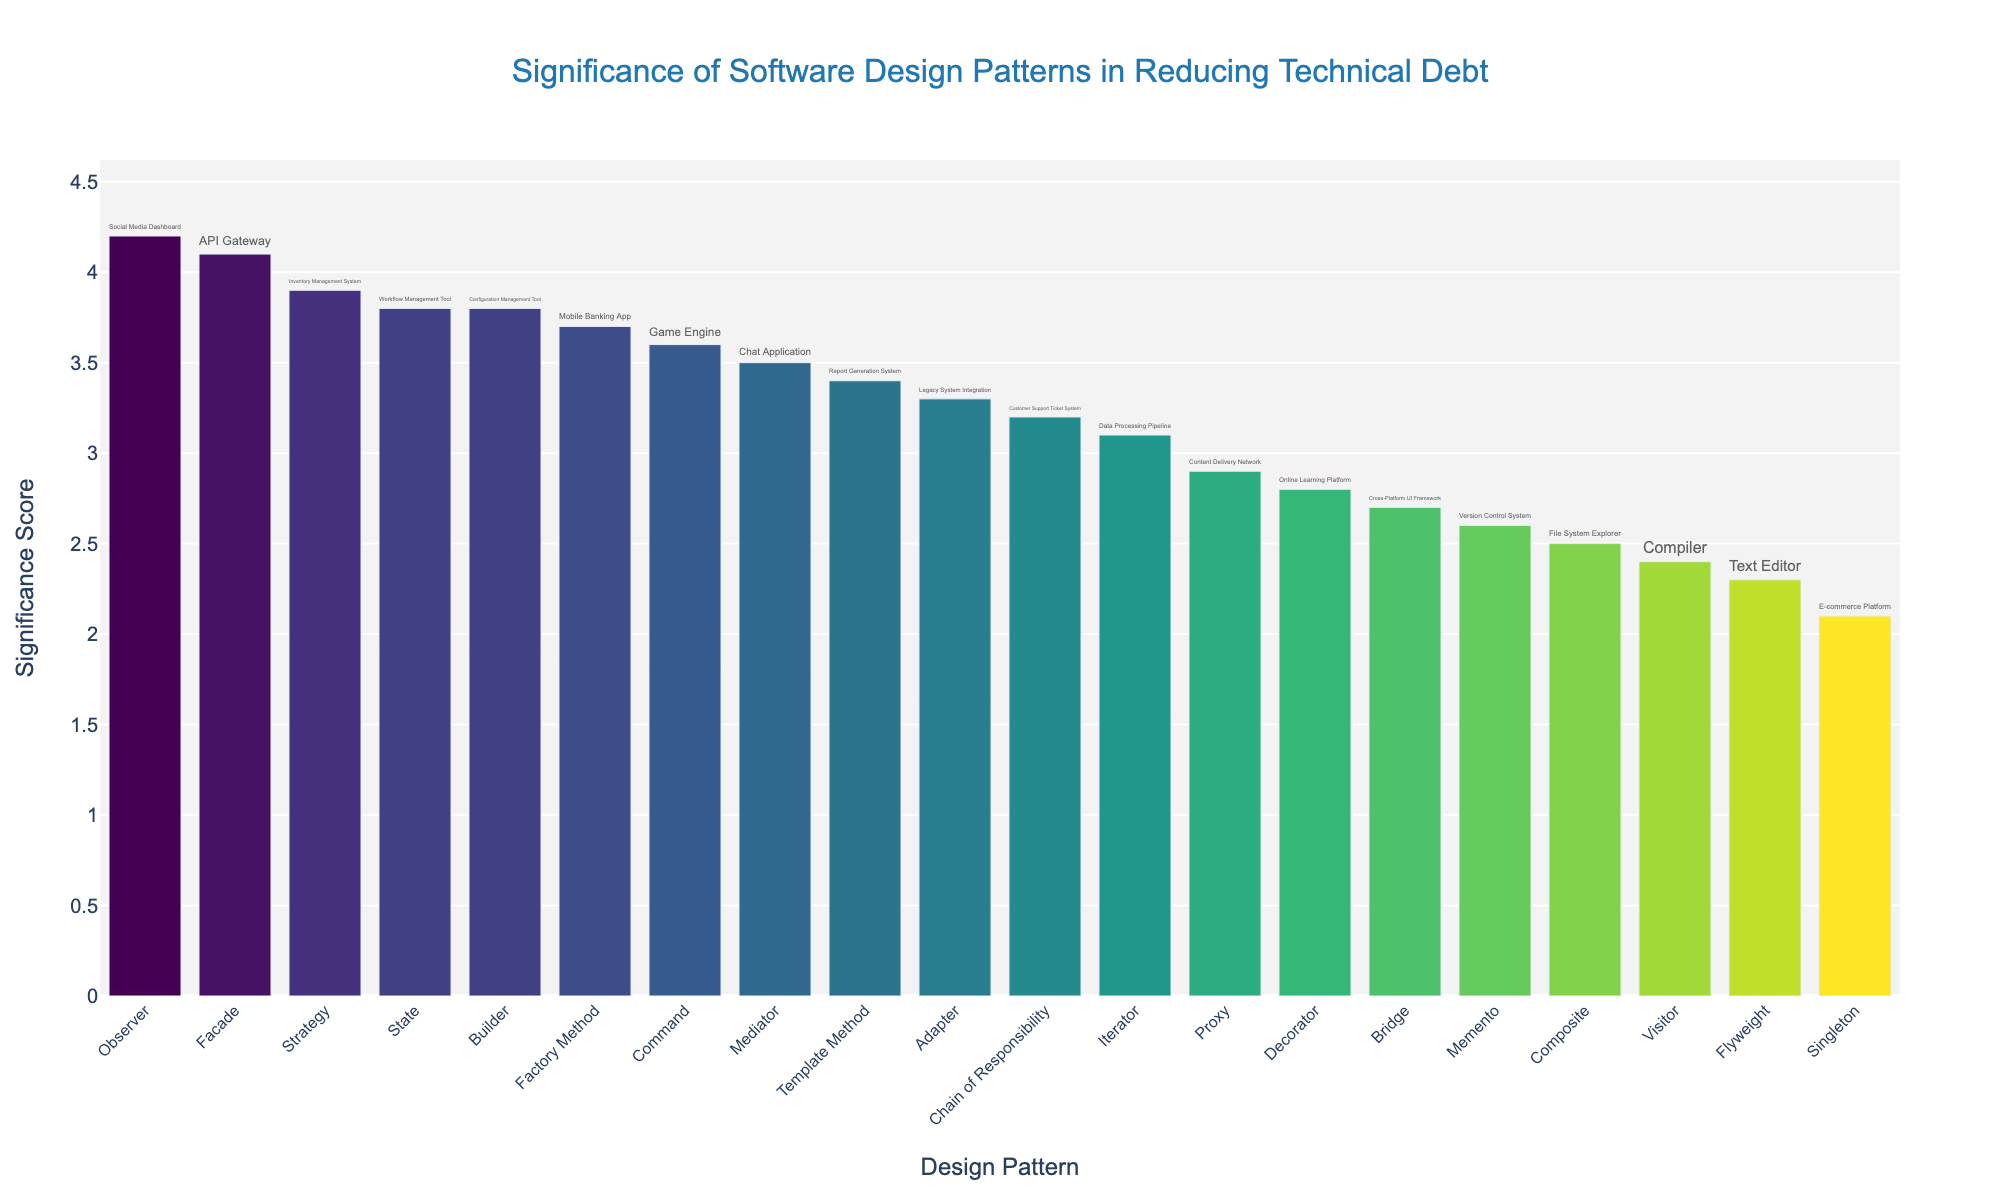What is the title of the figure? The title is typically displayed at the top of the figure. In this case, the title reads 'Significance of Software Design Patterns in Reducing Technical Debt'.
Answer: 'Significance of Software Design Patterns in Reducing Technical Debt' What are the x-axis and y-axis labels in the figure? The x-axis label is 'Design Pattern' and the y-axis label is 'Significance Score'. These labels help identify what each axis represents in the plot.
Answer: 'Design Pattern' (x-axis) and 'Significance Score' (y-axis) Which design pattern has the highest significance score? The figure shows bars representing each design pattern's significance score. The tallest bar corresponds to the design pattern with the highest score. In this case, 'Observer' has the highest significance score of 4.2.
Answer: 'Observer' Which project is associated with the 'Facade' pattern and what's its significance score? By locating the bar corresponding to 'Facade' on the x-axis and checking its hover text, it's indicated that the 'API Gateway' project is associated with 'Facade' and has a significance score of 4.1.
Answer: 'API Gateway' and 4.1 What are the three design patterns with the lowest significance scores? By identifying the three shortest bars in the figure, we find that 'Visitor', 'Flyweight', and 'Singleton' have the lowest significance scores, with respective scores of 2.4, 2.3, and 2.1.
Answer: 'Visitor', 'Flyweight', and 'Singleton' What is the average significance score of all the design patterns shown? To calculate the average, sum all the significance scores and divide by the number of design patterns. Sum = 61.8, number of patterns = 19, so average = 61.8 / 19 = 3.25.
Answer: 3.25 How many design patterns have a significance score greater than or equal to 3.7? Count the bars in the figure with heights corresponding to significance scores of 3.7 or more. These include 'Factory Method', 'Observer', 'Strategy', 'State', 'Facade', and 'Builder'. There are 6 such design patterns.
Answer: 6 Which design pattern related to 'Legacy System Integration' and what is its significance score? By checking the hover text for the 'Legacy System Integration' project, we find that it is associated with the 'Adapter' design pattern, which has a significance score of 3.3.
Answer: 'Adapter' and 3.3 How does the significance score of the 'Strategy' design pattern compare to that of the 'Template Method'? By comparing the heights of the bars for 'Strategy' and 'Template Method', we see that 'Strategy' has a higher significance score of 3.9 compared to 'Template Method's 3.4.
Answer: 'Strategy' is higher than 'Template Method' 